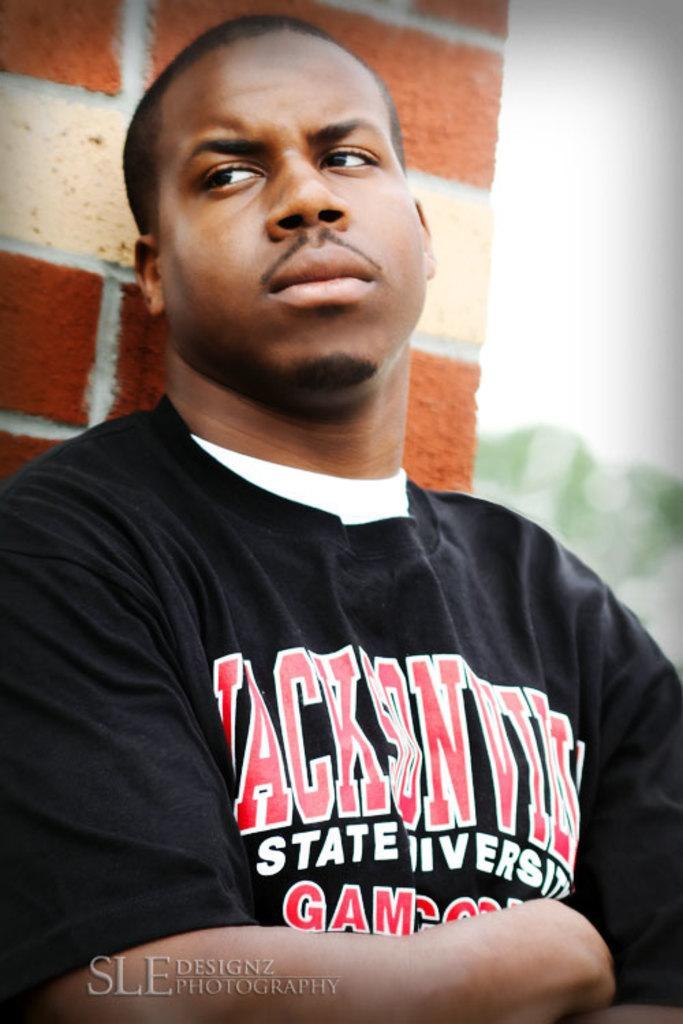Could you give a brief overview of what you see in this image? In this picture I can see a man is wearing black color t-shirt. On the t-shirt I can see something written on it. In the background I can see brick wall. Here I can see a watermark. 